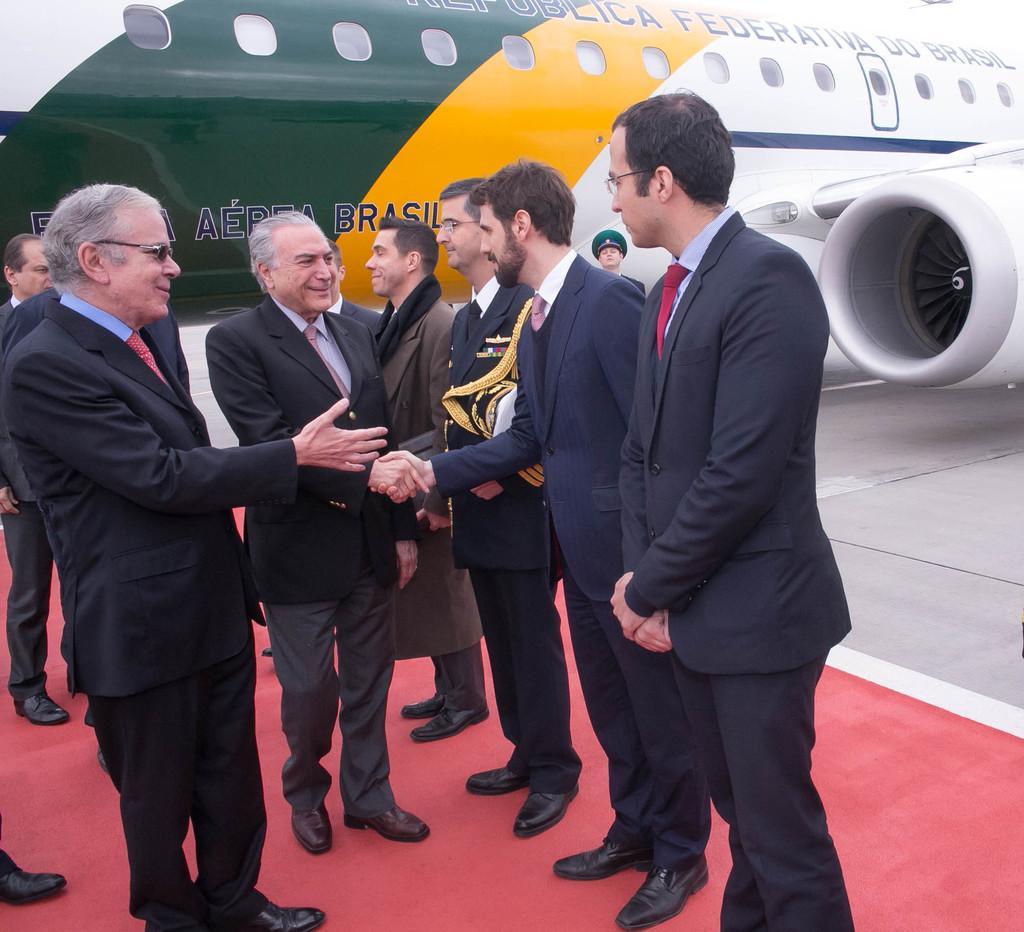Please provide a concise description of this image. In this image there are a few people standing and shaking hands, behind them there is a plane. 